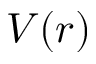Convert formula to latex. <formula><loc_0><loc_0><loc_500><loc_500>V ( r )</formula> 